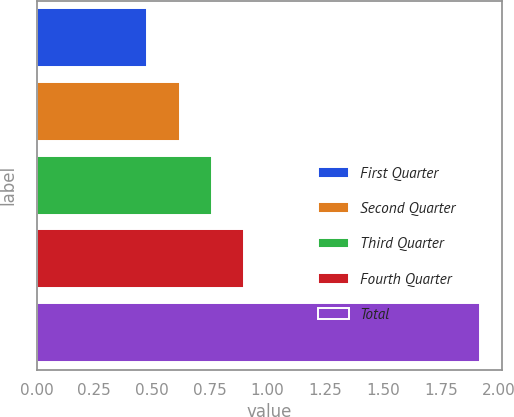<chart> <loc_0><loc_0><loc_500><loc_500><bar_chart><fcel>First Quarter<fcel>Second Quarter<fcel>Third Quarter<fcel>Fourth Quarter<fcel>Total<nl><fcel>0.48<fcel>0.62<fcel>0.76<fcel>0.9<fcel>1.92<nl></chart> 